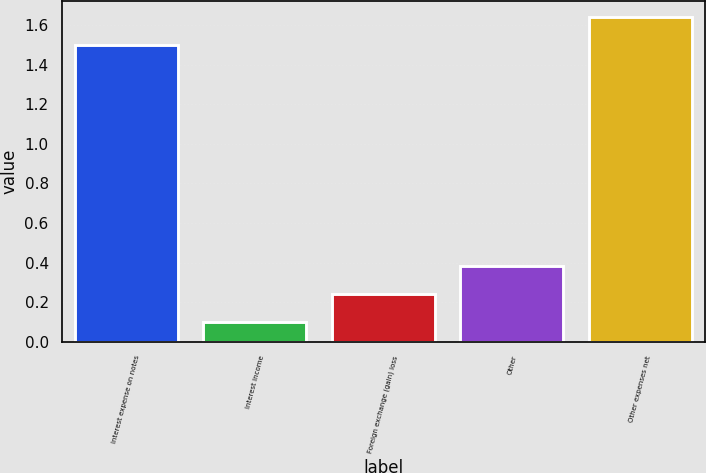<chart> <loc_0><loc_0><loc_500><loc_500><bar_chart><fcel>Interest expense on notes<fcel>Interest income<fcel>Foreign exchange (gain) loss<fcel>Other<fcel>Other expenses net<nl><fcel>1.5<fcel>0.1<fcel>0.24<fcel>0.38<fcel>1.64<nl></chart> 